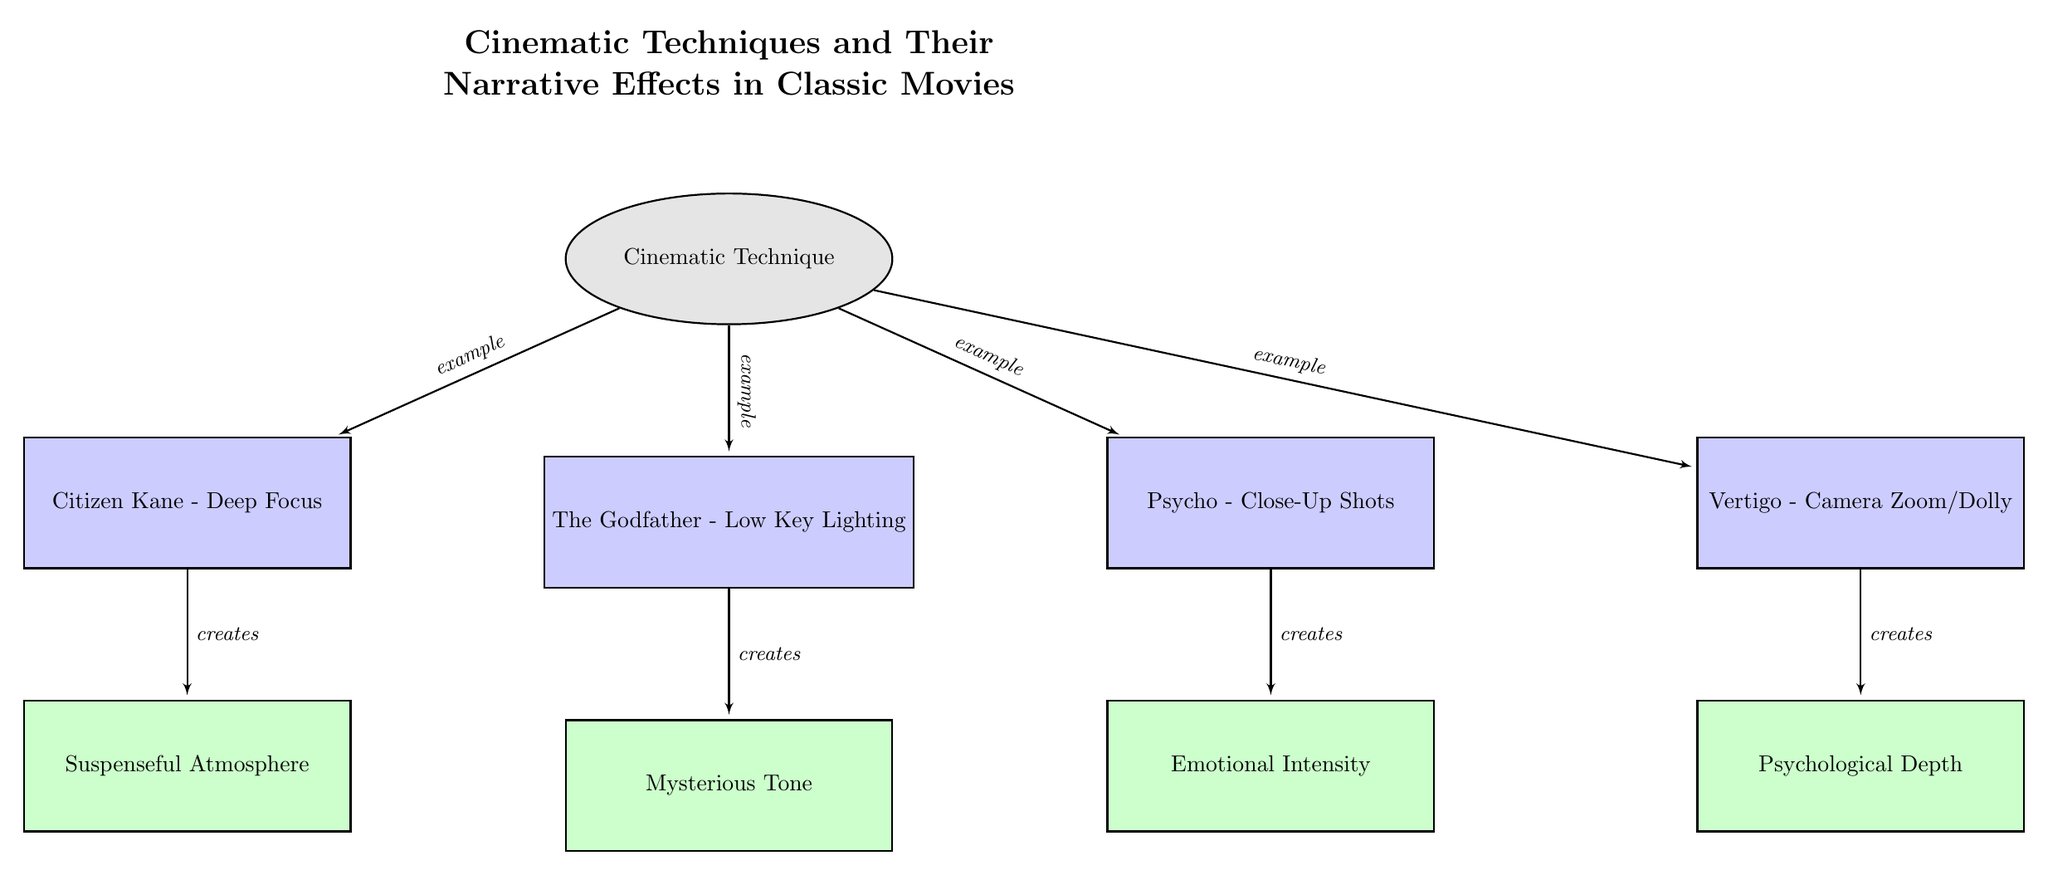What is the cinematic technique used in "Citizen Kane"? The diagram indicates that the cinematic technique used in "Citizen Kane" is Deep Focus, which is directly labeled under the corresponding movie node.
Answer: Deep Focus How many movies are listed in the diagram? By counting the movie nodes directly within the diagram, there are four listed movies: "Citizen Kane," "The Godfather," "Psycho," and "Vertigo."
Answer: 4 What narrative effect is created by the cinematic technique of Low Key Lighting in "The Godfather"? From the diagram, it's shown that Low Key Lighting creates a Mysterious Tone, which is connected to "The Godfather" movie node.
Answer: Mysterious Tone Which cinematic technique corresponds to the narrative effect of Emotional Intensity? The diagram clearly indicates that Close-Up Shots from the movie "Psycho" create the narrative effect of Emotional Intensity.
Answer: Close-Up Shots What is the relationship between "Vertigo" and Psychological Depth? The diagram shows a directed edge labeled "creates" originating from the "Vertigo" movie node and pointing toward the effect node for Psychological Depth, indicating that "Vertigo" directly creates this effect.
Answer: creates Which movie utilizes Camera Zoom/Dolly as a cinematic technique? The diagram contains "Vertigo" as the movie node that is associated with the Camera Zoom/Dolly technique, as labeled directly beneath it.
Answer: Vertigo What are the four narrative effects mentioned in the diagram? The effects can be identified clearly from the diagram, which lists them as: Suspenseful Atmosphere, Mysterious Tone, Emotional Intensity, and Psychological Depth.
Answer: Suspenseful Atmosphere, Mysterious Tone, Emotional Intensity, Psychological Depth Which effect is linked with Deep Focus? The diagram connects Deep Focus from "Citizen Kane" with the effect labeled Suspenseful Atmosphere, shown clearly through the connecting line.
Answer: Suspenseful Atmosphere In the diagram, how does Camera Zoom/Dolly translate to narrative effects? The diagram illustrates that the technique linked to Camera Zoom/Dolly from "Vertigo" is translated into the narrative effect of Psychological Depth, highlighted by the creating relationship.
Answer: Psychological Depth 